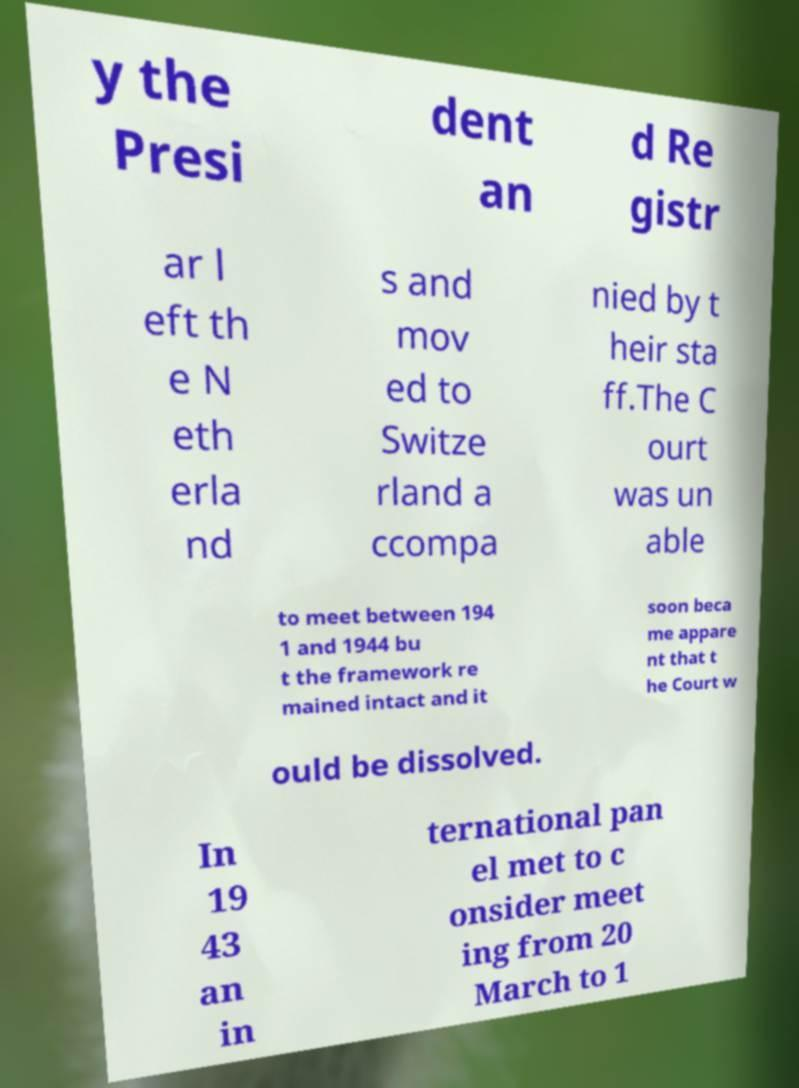For documentation purposes, I need the text within this image transcribed. Could you provide that? y the Presi dent an d Re gistr ar l eft th e N eth erla nd s and mov ed to Switze rland a ccompa nied by t heir sta ff.The C ourt was un able to meet between 194 1 and 1944 bu t the framework re mained intact and it soon beca me appare nt that t he Court w ould be dissolved. In 19 43 an in ternational pan el met to c onsider meet ing from 20 March to 1 